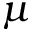Convert formula to latex. <formula><loc_0><loc_0><loc_500><loc_500>\mu</formula> 